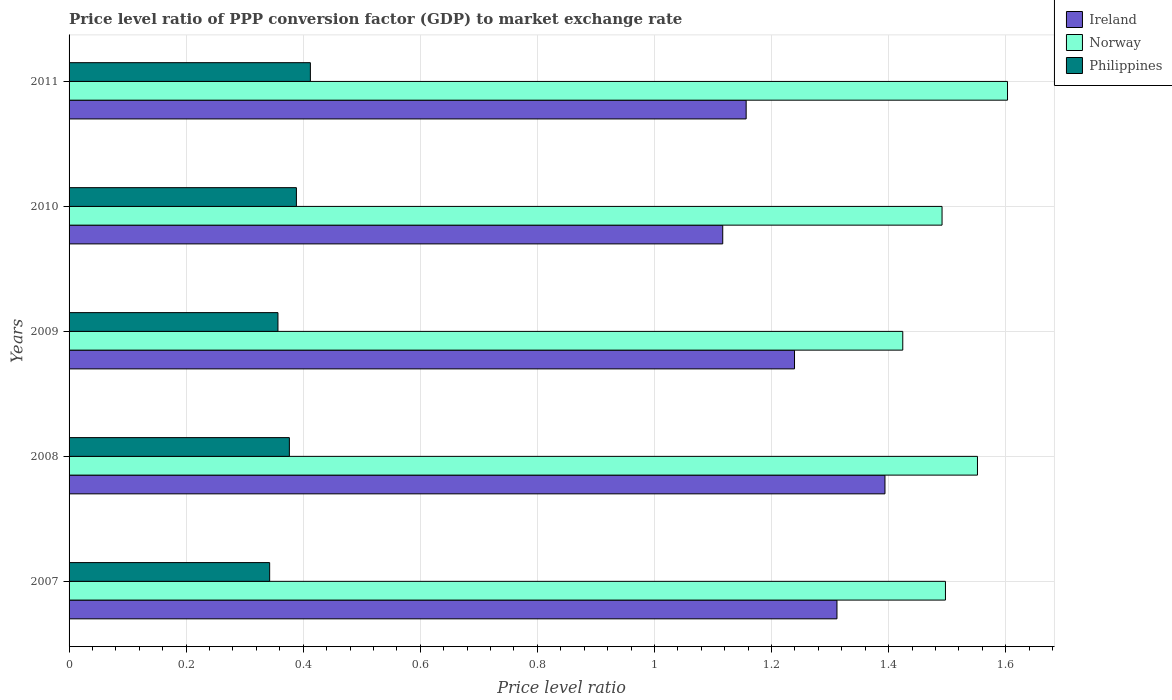How many different coloured bars are there?
Make the answer very short. 3. How many groups of bars are there?
Your answer should be compact. 5. How many bars are there on the 3rd tick from the bottom?
Your response must be concise. 3. What is the label of the 3rd group of bars from the top?
Ensure brevity in your answer.  2009. In how many cases, is the number of bars for a given year not equal to the number of legend labels?
Provide a short and direct response. 0. What is the price level ratio in Ireland in 2010?
Your response must be concise. 1.12. Across all years, what is the maximum price level ratio in Philippines?
Your response must be concise. 0.41. Across all years, what is the minimum price level ratio in Philippines?
Keep it short and to the point. 0.34. In which year was the price level ratio in Norway maximum?
Provide a succinct answer. 2011. What is the total price level ratio in Philippines in the graph?
Make the answer very short. 1.88. What is the difference between the price level ratio in Norway in 2007 and that in 2010?
Ensure brevity in your answer.  0.01. What is the difference between the price level ratio in Philippines in 2010 and the price level ratio in Norway in 2009?
Provide a short and direct response. -1.04. What is the average price level ratio in Philippines per year?
Make the answer very short. 0.38. In the year 2011, what is the difference between the price level ratio in Philippines and price level ratio in Norway?
Ensure brevity in your answer.  -1.19. In how many years, is the price level ratio in Norway greater than 0.52 ?
Keep it short and to the point. 5. What is the ratio of the price level ratio in Philippines in 2007 to that in 2009?
Give a very brief answer. 0.96. Is the price level ratio in Norway in 2008 less than that in 2009?
Make the answer very short. No. What is the difference between the highest and the second highest price level ratio in Philippines?
Give a very brief answer. 0.02. What is the difference between the highest and the lowest price level ratio in Ireland?
Make the answer very short. 0.28. What does the 3rd bar from the top in 2011 represents?
Keep it short and to the point. Ireland. What does the 3rd bar from the bottom in 2007 represents?
Your answer should be compact. Philippines. What is the difference between two consecutive major ticks on the X-axis?
Your answer should be very brief. 0.2. Are the values on the major ticks of X-axis written in scientific E-notation?
Keep it short and to the point. No. Does the graph contain grids?
Make the answer very short. Yes. How many legend labels are there?
Give a very brief answer. 3. How are the legend labels stacked?
Give a very brief answer. Vertical. What is the title of the graph?
Provide a short and direct response. Price level ratio of PPP conversion factor (GDP) to market exchange rate. Does "Solomon Islands" appear as one of the legend labels in the graph?
Provide a succinct answer. No. What is the label or title of the X-axis?
Your response must be concise. Price level ratio. What is the label or title of the Y-axis?
Your answer should be compact. Years. What is the Price level ratio in Ireland in 2007?
Provide a short and direct response. 1.31. What is the Price level ratio in Norway in 2007?
Your answer should be very brief. 1.5. What is the Price level ratio of Philippines in 2007?
Your answer should be compact. 0.34. What is the Price level ratio of Ireland in 2008?
Offer a terse response. 1.39. What is the Price level ratio in Norway in 2008?
Offer a terse response. 1.55. What is the Price level ratio of Philippines in 2008?
Make the answer very short. 0.38. What is the Price level ratio of Ireland in 2009?
Offer a terse response. 1.24. What is the Price level ratio in Norway in 2009?
Your response must be concise. 1.42. What is the Price level ratio in Philippines in 2009?
Your answer should be compact. 0.36. What is the Price level ratio of Ireland in 2010?
Make the answer very short. 1.12. What is the Price level ratio of Norway in 2010?
Make the answer very short. 1.49. What is the Price level ratio of Philippines in 2010?
Make the answer very short. 0.39. What is the Price level ratio of Ireland in 2011?
Keep it short and to the point. 1.16. What is the Price level ratio of Norway in 2011?
Offer a very short reply. 1.6. What is the Price level ratio in Philippines in 2011?
Ensure brevity in your answer.  0.41. Across all years, what is the maximum Price level ratio in Ireland?
Provide a succinct answer. 1.39. Across all years, what is the maximum Price level ratio of Norway?
Provide a short and direct response. 1.6. Across all years, what is the maximum Price level ratio in Philippines?
Give a very brief answer. 0.41. Across all years, what is the minimum Price level ratio in Ireland?
Offer a terse response. 1.12. Across all years, what is the minimum Price level ratio of Norway?
Give a very brief answer. 1.42. Across all years, what is the minimum Price level ratio of Philippines?
Provide a succinct answer. 0.34. What is the total Price level ratio in Ireland in the graph?
Your answer should be compact. 6.22. What is the total Price level ratio in Norway in the graph?
Your response must be concise. 7.57. What is the total Price level ratio in Philippines in the graph?
Provide a succinct answer. 1.88. What is the difference between the Price level ratio of Ireland in 2007 and that in 2008?
Provide a short and direct response. -0.08. What is the difference between the Price level ratio of Norway in 2007 and that in 2008?
Give a very brief answer. -0.05. What is the difference between the Price level ratio in Philippines in 2007 and that in 2008?
Keep it short and to the point. -0.03. What is the difference between the Price level ratio in Ireland in 2007 and that in 2009?
Provide a succinct answer. 0.07. What is the difference between the Price level ratio in Norway in 2007 and that in 2009?
Your answer should be compact. 0.07. What is the difference between the Price level ratio in Philippines in 2007 and that in 2009?
Your response must be concise. -0.01. What is the difference between the Price level ratio in Ireland in 2007 and that in 2010?
Keep it short and to the point. 0.2. What is the difference between the Price level ratio of Norway in 2007 and that in 2010?
Offer a very short reply. 0.01. What is the difference between the Price level ratio in Philippines in 2007 and that in 2010?
Offer a very short reply. -0.05. What is the difference between the Price level ratio in Ireland in 2007 and that in 2011?
Give a very brief answer. 0.16. What is the difference between the Price level ratio of Norway in 2007 and that in 2011?
Give a very brief answer. -0.11. What is the difference between the Price level ratio in Philippines in 2007 and that in 2011?
Your answer should be very brief. -0.07. What is the difference between the Price level ratio of Ireland in 2008 and that in 2009?
Your answer should be compact. 0.15. What is the difference between the Price level ratio in Norway in 2008 and that in 2009?
Make the answer very short. 0.13. What is the difference between the Price level ratio of Philippines in 2008 and that in 2009?
Make the answer very short. 0.02. What is the difference between the Price level ratio in Ireland in 2008 and that in 2010?
Provide a short and direct response. 0.28. What is the difference between the Price level ratio in Norway in 2008 and that in 2010?
Keep it short and to the point. 0.06. What is the difference between the Price level ratio in Philippines in 2008 and that in 2010?
Your response must be concise. -0.01. What is the difference between the Price level ratio of Ireland in 2008 and that in 2011?
Offer a terse response. 0.24. What is the difference between the Price level ratio in Norway in 2008 and that in 2011?
Offer a terse response. -0.05. What is the difference between the Price level ratio of Philippines in 2008 and that in 2011?
Provide a short and direct response. -0.04. What is the difference between the Price level ratio of Ireland in 2009 and that in 2010?
Keep it short and to the point. 0.12. What is the difference between the Price level ratio of Norway in 2009 and that in 2010?
Your answer should be compact. -0.07. What is the difference between the Price level ratio of Philippines in 2009 and that in 2010?
Ensure brevity in your answer.  -0.03. What is the difference between the Price level ratio of Ireland in 2009 and that in 2011?
Your response must be concise. 0.08. What is the difference between the Price level ratio of Norway in 2009 and that in 2011?
Provide a succinct answer. -0.18. What is the difference between the Price level ratio of Philippines in 2009 and that in 2011?
Keep it short and to the point. -0.06. What is the difference between the Price level ratio in Ireland in 2010 and that in 2011?
Your response must be concise. -0.04. What is the difference between the Price level ratio of Norway in 2010 and that in 2011?
Make the answer very short. -0.11. What is the difference between the Price level ratio of Philippines in 2010 and that in 2011?
Your answer should be very brief. -0.02. What is the difference between the Price level ratio of Ireland in 2007 and the Price level ratio of Norway in 2008?
Ensure brevity in your answer.  -0.24. What is the difference between the Price level ratio of Ireland in 2007 and the Price level ratio of Philippines in 2008?
Make the answer very short. 0.94. What is the difference between the Price level ratio of Norway in 2007 and the Price level ratio of Philippines in 2008?
Your answer should be compact. 1.12. What is the difference between the Price level ratio in Ireland in 2007 and the Price level ratio in Norway in 2009?
Offer a very short reply. -0.11. What is the difference between the Price level ratio in Ireland in 2007 and the Price level ratio in Philippines in 2009?
Provide a short and direct response. 0.95. What is the difference between the Price level ratio in Norway in 2007 and the Price level ratio in Philippines in 2009?
Keep it short and to the point. 1.14. What is the difference between the Price level ratio of Ireland in 2007 and the Price level ratio of Norway in 2010?
Offer a very short reply. -0.18. What is the difference between the Price level ratio of Ireland in 2007 and the Price level ratio of Philippines in 2010?
Your answer should be very brief. 0.92. What is the difference between the Price level ratio of Norway in 2007 and the Price level ratio of Philippines in 2010?
Your response must be concise. 1.11. What is the difference between the Price level ratio of Ireland in 2007 and the Price level ratio of Norway in 2011?
Offer a terse response. -0.29. What is the difference between the Price level ratio of Ireland in 2007 and the Price level ratio of Philippines in 2011?
Make the answer very short. 0.9. What is the difference between the Price level ratio in Norway in 2007 and the Price level ratio in Philippines in 2011?
Your response must be concise. 1.08. What is the difference between the Price level ratio in Ireland in 2008 and the Price level ratio in Norway in 2009?
Provide a short and direct response. -0.03. What is the difference between the Price level ratio of Ireland in 2008 and the Price level ratio of Philippines in 2009?
Keep it short and to the point. 1.04. What is the difference between the Price level ratio in Norway in 2008 and the Price level ratio in Philippines in 2009?
Provide a succinct answer. 1.2. What is the difference between the Price level ratio in Ireland in 2008 and the Price level ratio in Norway in 2010?
Offer a terse response. -0.1. What is the difference between the Price level ratio of Ireland in 2008 and the Price level ratio of Philippines in 2010?
Offer a terse response. 1.01. What is the difference between the Price level ratio of Norway in 2008 and the Price level ratio of Philippines in 2010?
Ensure brevity in your answer.  1.16. What is the difference between the Price level ratio in Ireland in 2008 and the Price level ratio in Norway in 2011?
Make the answer very short. -0.21. What is the difference between the Price level ratio of Ireland in 2008 and the Price level ratio of Philippines in 2011?
Make the answer very short. 0.98. What is the difference between the Price level ratio of Norway in 2008 and the Price level ratio of Philippines in 2011?
Provide a succinct answer. 1.14. What is the difference between the Price level ratio of Ireland in 2009 and the Price level ratio of Norway in 2010?
Offer a terse response. -0.25. What is the difference between the Price level ratio of Ireland in 2009 and the Price level ratio of Philippines in 2010?
Ensure brevity in your answer.  0.85. What is the difference between the Price level ratio of Norway in 2009 and the Price level ratio of Philippines in 2010?
Your answer should be compact. 1.04. What is the difference between the Price level ratio of Ireland in 2009 and the Price level ratio of Norway in 2011?
Offer a terse response. -0.36. What is the difference between the Price level ratio in Ireland in 2009 and the Price level ratio in Philippines in 2011?
Your response must be concise. 0.83. What is the difference between the Price level ratio in Norway in 2009 and the Price level ratio in Philippines in 2011?
Your response must be concise. 1.01. What is the difference between the Price level ratio of Ireland in 2010 and the Price level ratio of Norway in 2011?
Offer a terse response. -0.49. What is the difference between the Price level ratio of Ireland in 2010 and the Price level ratio of Philippines in 2011?
Give a very brief answer. 0.7. What is the difference between the Price level ratio of Norway in 2010 and the Price level ratio of Philippines in 2011?
Offer a terse response. 1.08. What is the average Price level ratio of Ireland per year?
Keep it short and to the point. 1.24. What is the average Price level ratio in Norway per year?
Offer a very short reply. 1.51. What is the average Price level ratio in Philippines per year?
Offer a terse response. 0.38. In the year 2007, what is the difference between the Price level ratio of Ireland and Price level ratio of Norway?
Ensure brevity in your answer.  -0.19. In the year 2007, what is the difference between the Price level ratio in Ireland and Price level ratio in Philippines?
Offer a very short reply. 0.97. In the year 2007, what is the difference between the Price level ratio of Norway and Price level ratio of Philippines?
Provide a short and direct response. 1.15. In the year 2008, what is the difference between the Price level ratio in Ireland and Price level ratio in Norway?
Your response must be concise. -0.16. In the year 2008, what is the difference between the Price level ratio in Ireland and Price level ratio in Philippines?
Provide a succinct answer. 1.02. In the year 2008, what is the difference between the Price level ratio in Norway and Price level ratio in Philippines?
Make the answer very short. 1.18. In the year 2009, what is the difference between the Price level ratio of Ireland and Price level ratio of Norway?
Give a very brief answer. -0.18. In the year 2009, what is the difference between the Price level ratio of Ireland and Price level ratio of Philippines?
Provide a succinct answer. 0.88. In the year 2009, what is the difference between the Price level ratio in Norway and Price level ratio in Philippines?
Make the answer very short. 1.07. In the year 2010, what is the difference between the Price level ratio of Ireland and Price level ratio of Norway?
Your response must be concise. -0.37. In the year 2010, what is the difference between the Price level ratio in Ireland and Price level ratio in Philippines?
Provide a succinct answer. 0.73. In the year 2010, what is the difference between the Price level ratio in Norway and Price level ratio in Philippines?
Give a very brief answer. 1.1. In the year 2011, what is the difference between the Price level ratio in Ireland and Price level ratio in Norway?
Ensure brevity in your answer.  -0.45. In the year 2011, what is the difference between the Price level ratio of Ireland and Price level ratio of Philippines?
Make the answer very short. 0.74. In the year 2011, what is the difference between the Price level ratio in Norway and Price level ratio in Philippines?
Your answer should be very brief. 1.19. What is the ratio of the Price level ratio in Norway in 2007 to that in 2008?
Provide a short and direct response. 0.96. What is the ratio of the Price level ratio in Philippines in 2007 to that in 2008?
Offer a very short reply. 0.91. What is the ratio of the Price level ratio in Ireland in 2007 to that in 2009?
Keep it short and to the point. 1.06. What is the ratio of the Price level ratio in Norway in 2007 to that in 2009?
Offer a terse response. 1.05. What is the ratio of the Price level ratio of Philippines in 2007 to that in 2009?
Offer a very short reply. 0.96. What is the ratio of the Price level ratio in Ireland in 2007 to that in 2010?
Give a very brief answer. 1.17. What is the ratio of the Price level ratio of Norway in 2007 to that in 2010?
Offer a terse response. 1. What is the ratio of the Price level ratio in Philippines in 2007 to that in 2010?
Offer a very short reply. 0.88. What is the ratio of the Price level ratio of Ireland in 2007 to that in 2011?
Ensure brevity in your answer.  1.13. What is the ratio of the Price level ratio in Norway in 2007 to that in 2011?
Your answer should be very brief. 0.93. What is the ratio of the Price level ratio in Philippines in 2007 to that in 2011?
Offer a very short reply. 0.83. What is the ratio of the Price level ratio in Ireland in 2008 to that in 2009?
Provide a short and direct response. 1.12. What is the ratio of the Price level ratio in Norway in 2008 to that in 2009?
Provide a short and direct response. 1.09. What is the ratio of the Price level ratio of Philippines in 2008 to that in 2009?
Provide a succinct answer. 1.05. What is the ratio of the Price level ratio of Ireland in 2008 to that in 2010?
Your response must be concise. 1.25. What is the ratio of the Price level ratio in Norway in 2008 to that in 2010?
Ensure brevity in your answer.  1.04. What is the ratio of the Price level ratio in Philippines in 2008 to that in 2010?
Your answer should be compact. 0.97. What is the ratio of the Price level ratio in Ireland in 2008 to that in 2011?
Ensure brevity in your answer.  1.21. What is the ratio of the Price level ratio in Philippines in 2008 to that in 2011?
Make the answer very short. 0.91. What is the ratio of the Price level ratio of Ireland in 2009 to that in 2010?
Offer a terse response. 1.11. What is the ratio of the Price level ratio in Norway in 2009 to that in 2010?
Your answer should be very brief. 0.95. What is the ratio of the Price level ratio of Philippines in 2009 to that in 2010?
Make the answer very short. 0.92. What is the ratio of the Price level ratio of Ireland in 2009 to that in 2011?
Ensure brevity in your answer.  1.07. What is the ratio of the Price level ratio in Norway in 2009 to that in 2011?
Provide a short and direct response. 0.89. What is the ratio of the Price level ratio of Philippines in 2009 to that in 2011?
Keep it short and to the point. 0.87. What is the ratio of the Price level ratio of Ireland in 2010 to that in 2011?
Provide a short and direct response. 0.97. What is the ratio of the Price level ratio in Norway in 2010 to that in 2011?
Ensure brevity in your answer.  0.93. What is the ratio of the Price level ratio in Philippines in 2010 to that in 2011?
Provide a succinct answer. 0.94. What is the difference between the highest and the second highest Price level ratio of Ireland?
Keep it short and to the point. 0.08. What is the difference between the highest and the second highest Price level ratio in Norway?
Offer a terse response. 0.05. What is the difference between the highest and the second highest Price level ratio in Philippines?
Keep it short and to the point. 0.02. What is the difference between the highest and the lowest Price level ratio of Ireland?
Offer a terse response. 0.28. What is the difference between the highest and the lowest Price level ratio of Norway?
Give a very brief answer. 0.18. What is the difference between the highest and the lowest Price level ratio in Philippines?
Make the answer very short. 0.07. 